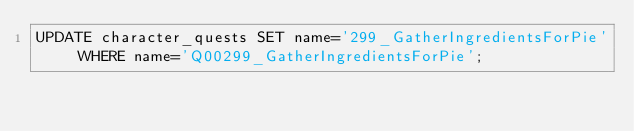Convert code to text. <code><loc_0><loc_0><loc_500><loc_500><_SQL_>UPDATE character_quests SET name='299_GatherIngredientsForPie' WHERE name='Q00299_GatherIngredientsForPie';</code> 